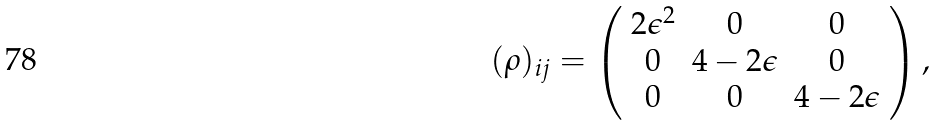Convert formula to latex. <formula><loc_0><loc_0><loc_500><loc_500>( \rho ) _ { i j } = \left ( \begin{array} { c c c } 2 \epsilon ^ { 2 } & 0 & 0 \\ 0 & 4 - 2 \epsilon & 0 \\ 0 & 0 & 4 - 2 \epsilon \end{array} \right ) ,</formula> 